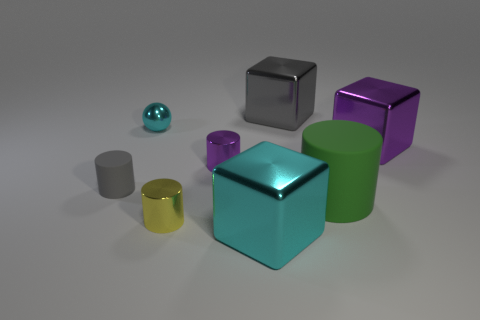Subtract 1 cylinders. How many cylinders are left? 3 Add 1 gray rubber cylinders. How many objects exist? 9 Subtract all cubes. How many objects are left? 5 Subtract all green matte cylinders. Subtract all gray matte spheres. How many objects are left? 7 Add 1 large cylinders. How many large cylinders are left? 2 Add 8 green rubber cylinders. How many green rubber cylinders exist? 9 Subtract 0 red cubes. How many objects are left? 8 